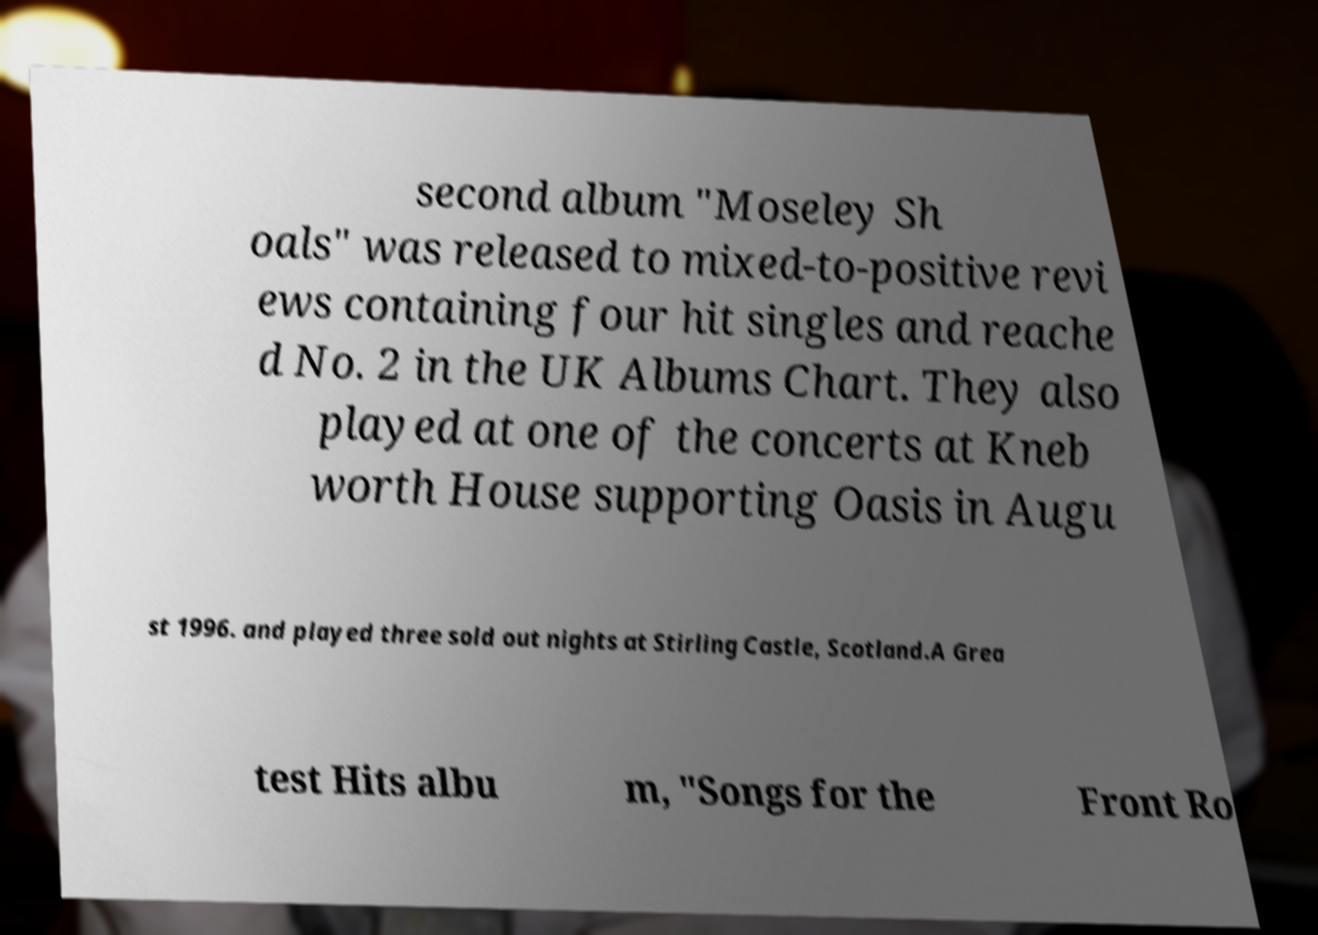For documentation purposes, I need the text within this image transcribed. Could you provide that? second album "Moseley Sh oals" was released to mixed-to-positive revi ews containing four hit singles and reache d No. 2 in the UK Albums Chart. They also played at one of the concerts at Kneb worth House supporting Oasis in Augu st 1996. and played three sold out nights at Stirling Castle, Scotland.A Grea test Hits albu m, "Songs for the Front Ro 